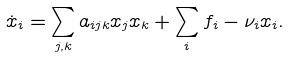Convert formula to latex. <formula><loc_0><loc_0><loc_500><loc_500>\dot { x } _ { i } = \sum _ { j , k } a _ { i j k } x _ { j } x _ { k } + \sum _ { i } f _ { i } - \nu _ { i } x _ { i } .</formula> 